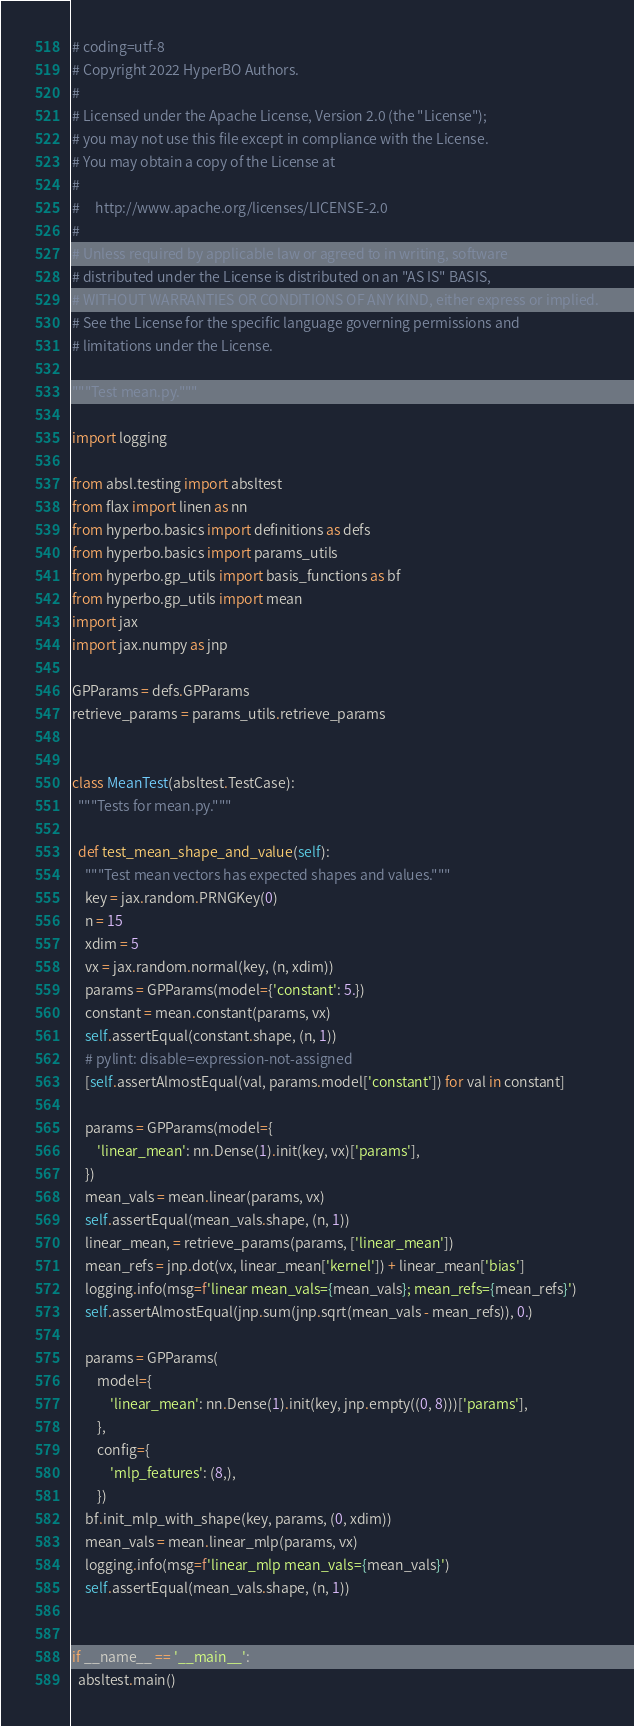<code> <loc_0><loc_0><loc_500><loc_500><_Python_># coding=utf-8
# Copyright 2022 HyperBO Authors.
#
# Licensed under the Apache License, Version 2.0 (the "License");
# you may not use this file except in compliance with the License.
# You may obtain a copy of the License at
#
#     http://www.apache.org/licenses/LICENSE-2.0
#
# Unless required by applicable law or agreed to in writing, software
# distributed under the License is distributed on an "AS IS" BASIS,
# WITHOUT WARRANTIES OR CONDITIONS OF ANY KIND, either express or implied.
# See the License for the specific language governing permissions and
# limitations under the License.

"""Test mean.py."""

import logging

from absl.testing import absltest
from flax import linen as nn
from hyperbo.basics import definitions as defs
from hyperbo.basics import params_utils
from hyperbo.gp_utils import basis_functions as bf
from hyperbo.gp_utils import mean
import jax
import jax.numpy as jnp

GPParams = defs.GPParams
retrieve_params = params_utils.retrieve_params


class MeanTest(absltest.TestCase):
  """Tests for mean.py."""

  def test_mean_shape_and_value(self):
    """Test mean vectors has expected shapes and values."""
    key = jax.random.PRNGKey(0)
    n = 15
    xdim = 5
    vx = jax.random.normal(key, (n, xdim))
    params = GPParams(model={'constant': 5.})
    constant = mean.constant(params, vx)
    self.assertEqual(constant.shape, (n, 1))
    # pylint: disable=expression-not-assigned
    [self.assertAlmostEqual(val, params.model['constant']) for val in constant]

    params = GPParams(model={
        'linear_mean': nn.Dense(1).init(key, vx)['params'],
    })
    mean_vals = mean.linear(params, vx)
    self.assertEqual(mean_vals.shape, (n, 1))
    linear_mean, = retrieve_params(params, ['linear_mean'])
    mean_refs = jnp.dot(vx, linear_mean['kernel']) + linear_mean['bias']
    logging.info(msg=f'linear mean_vals={mean_vals}; mean_refs={mean_refs}')
    self.assertAlmostEqual(jnp.sum(jnp.sqrt(mean_vals - mean_refs)), 0.)

    params = GPParams(
        model={
            'linear_mean': nn.Dense(1).init(key, jnp.empty((0, 8)))['params'],
        },
        config={
            'mlp_features': (8,),
        })
    bf.init_mlp_with_shape(key, params, (0, xdim))
    mean_vals = mean.linear_mlp(params, vx)
    logging.info(msg=f'linear_mlp mean_vals={mean_vals}')
    self.assertEqual(mean_vals.shape, (n, 1))


if __name__ == '__main__':
  absltest.main()
</code> 